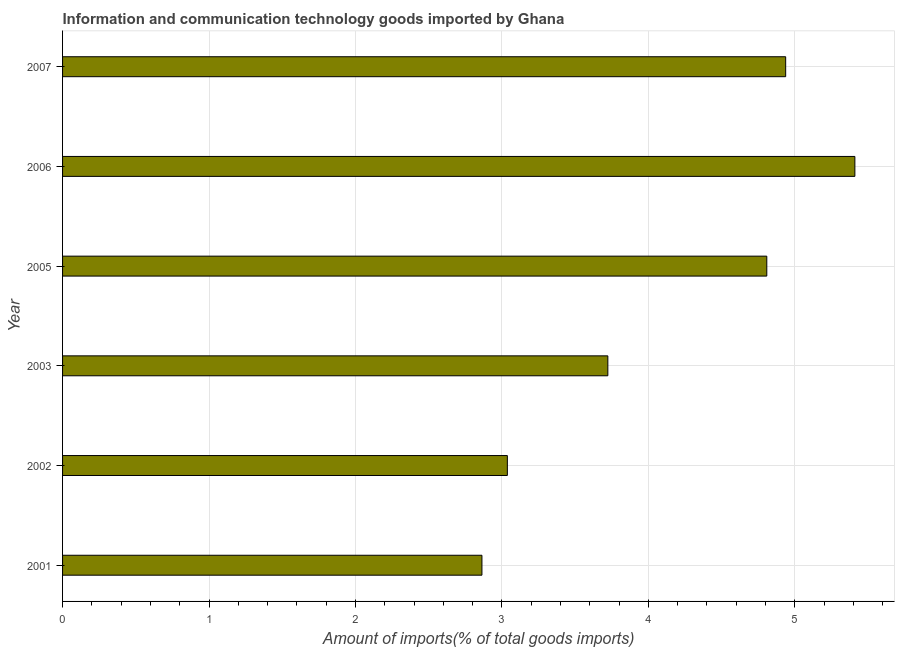Does the graph contain grids?
Provide a short and direct response. Yes. What is the title of the graph?
Your response must be concise. Information and communication technology goods imported by Ghana. What is the label or title of the X-axis?
Offer a very short reply. Amount of imports(% of total goods imports). What is the label or title of the Y-axis?
Provide a short and direct response. Year. What is the amount of ict goods imports in 2005?
Give a very brief answer. 4.81. Across all years, what is the maximum amount of ict goods imports?
Provide a short and direct response. 5.41. Across all years, what is the minimum amount of ict goods imports?
Ensure brevity in your answer.  2.86. What is the sum of the amount of ict goods imports?
Make the answer very short. 24.78. What is the difference between the amount of ict goods imports in 2002 and 2003?
Ensure brevity in your answer.  -0.69. What is the average amount of ict goods imports per year?
Your answer should be compact. 4.13. What is the median amount of ict goods imports?
Your response must be concise. 4.27. In how many years, is the amount of ict goods imports greater than 3.8 %?
Provide a succinct answer. 3. What is the ratio of the amount of ict goods imports in 2002 to that in 2006?
Offer a very short reply. 0.56. What is the difference between the highest and the second highest amount of ict goods imports?
Give a very brief answer. 0.47. What is the difference between the highest and the lowest amount of ict goods imports?
Ensure brevity in your answer.  2.55. How many bars are there?
Give a very brief answer. 6. How many years are there in the graph?
Make the answer very short. 6. What is the difference between two consecutive major ticks on the X-axis?
Your response must be concise. 1. What is the Amount of imports(% of total goods imports) in 2001?
Offer a very short reply. 2.86. What is the Amount of imports(% of total goods imports) of 2002?
Provide a short and direct response. 3.04. What is the Amount of imports(% of total goods imports) in 2003?
Your response must be concise. 3.72. What is the Amount of imports(% of total goods imports) in 2005?
Keep it short and to the point. 4.81. What is the Amount of imports(% of total goods imports) in 2006?
Give a very brief answer. 5.41. What is the Amount of imports(% of total goods imports) in 2007?
Your answer should be compact. 4.94. What is the difference between the Amount of imports(% of total goods imports) in 2001 and 2002?
Ensure brevity in your answer.  -0.17. What is the difference between the Amount of imports(% of total goods imports) in 2001 and 2003?
Your answer should be very brief. -0.86. What is the difference between the Amount of imports(% of total goods imports) in 2001 and 2005?
Your answer should be compact. -1.95. What is the difference between the Amount of imports(% of total goods imports) in 2001 and 2006?
Provide a succinct answer. -2.55. What is the difference between the Amount of imports(% of total goods imports) in 2001 and 2007?
Ensure brevity in your answer.  -2.07. What is the difference between the Amount of imports(% of total goods imports) in 2002 and 2003?
Your answer should be very brief. -0.69. What is the difference between the Amount of imports(% of total goods imports) in 2002 and 2005?
Your response must be concise. -1.77. What is the difference between the Amount of imports(% of total goods imports) in 2002 and 2006?
Your answer should be very brief. -2.37. What is the difference between the Amount of imports(% of total goods imports) in 2002 and 2007?
Make the answer very short. -1.9. What is the difference between the Amount of imports(% of total goods imports) in 2003 and 2005?
Provide a succinct answer. -1.09. What is the difference between the Amount of imports(% of total goods imports) in 2003 and 2006?
Your response must be concise. -1.69. What is the difference between the Amount of imports(% of total goods imports) in 2003 and 2007?
Provide a short and direct response. -1.21. What is the difference between the Amount of imports(% of total goods imports) in 2005 and 2006?
Make the answer very short. -0.6. What is the difference between the Amount of imports(% of total goods imports) in 2005 and 2007?
Provide a short and direct response. -0.13. What is the difference between the Amount of imports(% of total goods imports) in 2006 and 2007?
Offer a terse response. 0.47. What is the ratio of the Amount of imports(% of total goods imports) in 2001 to that in 2002?
Your answer should be compact. 0.94. What is the ratio of the Amount of imports(% of total goods imports) in 2001 to that in 2003?
Make the answer very short. 0.77. What is the ratio of the Amount of imports(% of total goods imports) in 2001 to that in 2005?
Your answer should be very brief. 0.6. What is the ratio of the Amount of imports(% of total goods imports) in 2001 to that in 2006?
Give a very brief answer. 0.53. What is the ratio of the Amount of imports(% of total goods imports) in 2001 to that in 2007?
Provide a short and direct response. 0.58. What is the ratio of the Amount of imports(% of total goods imports) in 2002 to that in 2003?
Your answer should be compact. 0.82. What is the ratio of the Amount of imports(% of total goods imports) in 2002 to that in 2005?
Offer a terse response. 0.63. What is the ratio of the Amount of imports(% of total goods imports) in 2002 to that in 2006?
Keep it short and to the point. 0.56. What is the ratio of the Amount of imports(% of total goods imports) in 2002 to that in 2007?
Give a very brief answer. 0.61. What is the ratio of the Amount of imports(% of total goods imports) in 2003 to that in 2005?
Your answer should be compact. 0.77. What is the ratio of the Amount of imports(% of total goods imports) in 2003 to that in 2006?
Keep it short and to the point. 0.69. What is the ratio of the Amount of imports(% of total goods imports) in 2003 to that in 2007?
Your answer should be compact. 0.75. What is the ratio of the Amount of imports(% of total goods imports) in 2005 to that in 2006?
Keep it short and to the point. 0.89. What is the ratio of the Amount of imports(% of total goods imports) in 2006 to that in 2007?
Your answer should be compact. 1.1. 